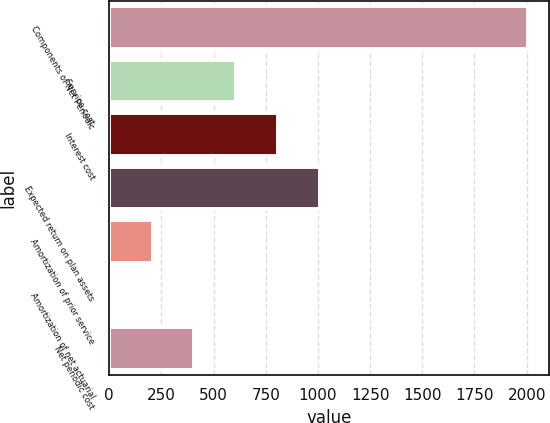Convert chart to OTSL. <chart><loc_0><loc_0><loc_500><loc_500><bar_chart><fcel>Components of Net Periodic<fcel>Service cost<fcel>Interest cost<fcel>Expected return on plan assets<fcel>Amortization of prior service<fcel>Amortization of net actuarial<fcel>Net periodic cost<nl><fcel>2008<fcel>608<fcel>808<fcel>1008<fcel>208<fcel>8<fcel>408<nl></chart> 